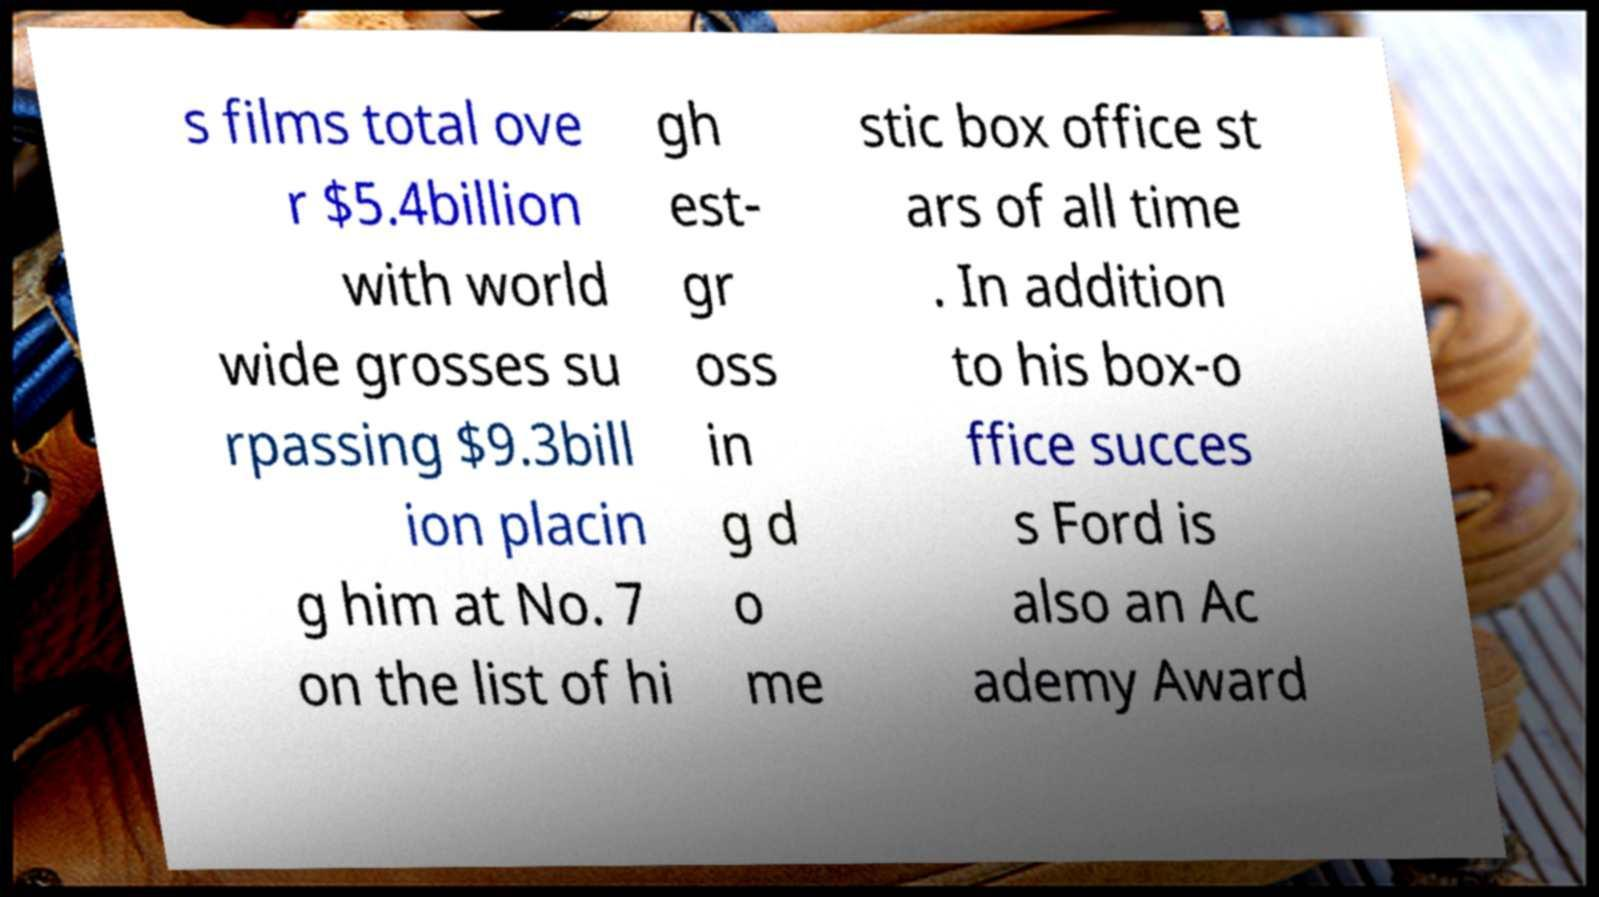For documentation purposes, I need the text within this image transcribed. Could you provide that? s films total ove r $5.4billion with world wide grosses su rpassing $9.3bill ion placin g him at No. 7 on the list of hi gh est- gr oss in g d o me stic box office st ars of all time . In addition to his box-o ffice succes s Ford is also an Ac ademy Award 